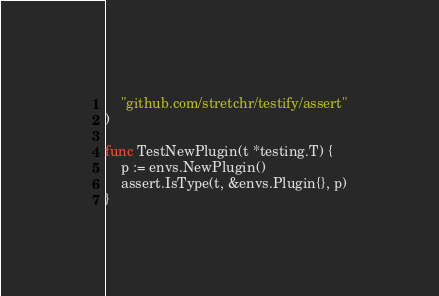<code> <loc_0><loc_0><loc_500><loc_500><_Go_>	"github.com/stretchr/testify/assert"
)

func TestNewPlugin(t *testing.T) {
	p := envs.NewPlugin()
	assert.IsType(t, &envs.Plugin{}, p)
}
</code> 